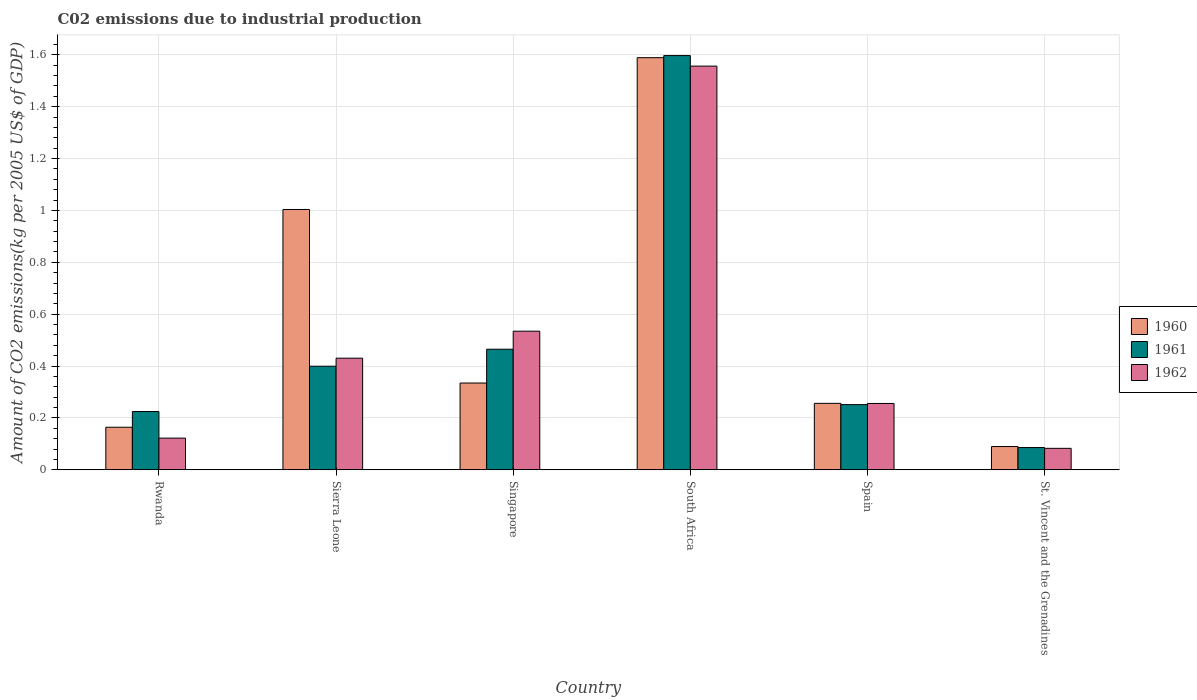Are the number of bars per tick equal to the number of legend labels?
Make the answer very short. Yes. How many bars are there on the 6th tick from the left?
Your answer should be very brief. 3. What is the label of the 4th group of bars from the left?
Keep it short and to the point. South Africa. What is the amount of CO2 emitted due to industrial production in 1962 in South Africa?
Your answer should be compact. 1.56. Across all countries, what is the maximum amount of CO2 emitted due to industrial production in 1960?
Make the answer very short. 1.59. Across all countries, what is the minimum amount of CO2 emitted due to industrial production in 1961?
Provide a succinct answer. 0.09. In which country was the amount of CO2 emitted due to industrial production in 1961 maximum?
Keep it short and to the point. South Africa. In which country was the amount of CO2 emitted due to industrial production in 1962 minimum?
Your response must be concise. St. Vincent and the Grenadines. What is the total amount of CO2 emitted due to industrial production in 1962 in the graph?
Ensure brevity in your answer.  2.98. What is the difference between the amount of CO2 emitted due to industrial production in 1960 in Rwanda and that in St. Vincent and the Grenadines?
Provide a short and direct response. 0.07. What is the difference between the amount of CO2 emitted due to industrial production in 1960 in Singapore and the amount of CO2 emitted due to industrial production in 1962 in Sierra Leone?
Offer a very short reply. -0.1. What is the average amount of CO2 emitted due to industrial production in 1960 per country?
Keep it short and to the point. 0.57. What is the difference between the amount of CO2 emitted due to industrial production of/in 1960 and amount of CO2 emitted due to industrial production of/in 1962 in Sierra Leone?
Your response must be concise. 0.57. In how many countries, is the amount of CO2 emitted due to industrial production in 1960 greater than 0.7600000000000001 kg?
Provide a short and direct response. 2. What is the ratio of the amount of CO2 emitted due to industrial production in 1960 in Rwanda to that in Spain?
Your answer should be compact. 0.64. Is the difference between the amount of CO2 emitted due to industrial production in 1960 in Sierra Leone and South Africa greater than the difference between the amount of CO2 emitted due to industrial production in 1962 in Sierra Leone and South Africa?
Give a very brief answer. Yes. What is the difference between the highest and the second highest amount of CO2 emitted due to industrial production in 1960?
Ensure brevity in your answer.  -1.25. What is the difference between the highest and the lowest amount of CO2 emitted due to industrial production in 1961?
Give a very brief answer. 1.51. In how many countries, is the amount of CO2 emitted due to industrial production in 1961 greater than the average amount of CO2 emitted due to industrial production in 1961 taken over all countries?
Your response must be concise. 1. Is the sum of the amount of CO2 emitted due to industrial production in 1960 in Rwanda and Spain greater than the maximum amount of CO2 emitted due to industrial production in 1962 across all countries?
Offer a very short reply. No. What does the 2nd bar from the left in Sierra Leone represents?
Keep it short and to the point. 1961. What does the 3rd bar from the right in Singapore represents?
Make the answer very short. 1960. Is it the case that in every country, the sum of the amount of CO2 emitted due to industrial production in 1961 and amount of CO2 emitted due to industrial production in 1962 is greater than the amount of CO2 emitted due to industrial production in 1960?
Your answer should be very brief. No. How many bars are there?
Provide a short and direct response. 18. What is the difference between two consecutive major ticks on the Y-axis?
Your answer should be compact. 0.2. Does the graph contain grids?
Make the answer very short. Yes. How are the legend labels stacked?
Ensure brevity in your answer.  Vertical. What is the title of the graph?
Offer a very short reply. C02 emissions due to industrial production. Does "1994" appear as one of the legend labels in the graph?
Offer a terse response. No. What is the label or title of the Y-axis?
Your answer should be very brief. Amount of CO2 emissions(kg per 2005 US$ of GDP). What is the Amount of CO2 emissions(kg per 2005 US$ of GDP) of 1960 in Rwanda?
Ensure brevity in your answer.  0.16. What is the Amount of CO2 emissions(kg per 2005 US$ of GDP) of 1961 in Rwanda?
Keep it short and to the point. 0.22. What is the Amount of CO2 emissions(kg per 2005 US$ of GDP) in 1962 in Rwanda?
Ensure brevity in your answer.  0.12. What is the Amount of CO2 emissions(kg per 2005 US$ of GDP) in 1960 in Sierra Leone?
Provide a short and direct response. 1. What is the Amount of CO2 emissions(kg per 2005 US$ of GDP) of 1961 in Sierra Leone?
Provide a short and direct response. 0.4. What is the Amount of CO2 emissions(kg per 2005 US$ of GDP) in 1962 in Sierra Leone?
Make the answer very short. 0.43. What is the Amount of CO2 emissions(kg per 2005 US$ of GDP) of 1960 in Singapore?
Your response must be concise. 0.33. What is the Amount of CO2 emissions(kg per 2005 US$ of GDP) in 1961 in Singapore?
Keep it short and to the point. 0.46. What is the Amount of CO2 emissions(kg per 2005 US$ of GDP) of 1962 in Singapore?
Offer a very short reply. 0.53. What is the Amount of CO2 emissions(kg per 2005 US$ of GDP) of 1960 in South Africa?
Provide a short and direct response. 1.59. What is the Amount of CO2 emissions(kg per 2005 US$ of GDP) of 1961 in South Africa?
Your answer should be compact. 1.6. What is the Amount of CO2 emissions(kg per 2005 US$ of GDP) of 1962 in South Africa?
Offer a terse response. 1.56. What is the Amount of CO2 emissions(kg per 2005 US$ of GDP) in 1960 in Spain?
Offer a terse response. 0.26. What is the Amount of CO2 emissions(kg per 2005 US$ of GDP) of 1961 in Spain?
Provide a short and direct response. 0.25. What is the Amount of CO2 emissions(kg per 2005 US$ of GDP) of 1962 in Spain?
Provide a short and direct response. 0.26. What is the Amount of CO2 emissions(kg per 2005 US$ of GDP) of 1960 in St. Vincent and the Grenadines?
Your answer should be compact. 0.09. What is the Amount of CO2 emissions(kg per 2005 US$ of GDP) in 1961 in St. Vincent and the Grenadines?
Ensure brevity in your answer.  0.09. What is the Amount of CO2 emissions(kg per 2005 US$ of GDP) in 1962 in St. Vincent and the Grenadines?
Your answer should be very brief. 0.08. Across all countries, what is the maximum Amount of CO2 emissions(kg per 2005 US$ of GDP) in 1960?
Provide a short and direct response. 1.59. Across all countries, what is the maximum Amount of CO2 emissions(kg per 2005 US$ of GDP) in 1961?
Offer a terse response. 1.6. Across all countries, what is the maximum Amount of CO2 emissions(kg per 2005 US$ of GDP) of 1962?
Your answer should be compact. 1.56. Across all countries, what is the minimum Amount of CO2 emissions(kg per 2005 US$ of GDP) of 1960?
Your response must be concise. 0.09. Across all countries, what is the minimum Amount of CO2 emissions(kg per 2005 US$ of GDP) in 1961?
Offer a very short reply. 0.09. Across all countries, what is the minimum Amount of CO2 emissions(kg per 2005 US$ of GDP) of 1962?
Your answer should be compact. 0.08. What is the total Amount of CO2 emissions(kg per 2005 US$ of GDP) in 1960 in the graph?
Ensure brevity in your answer.  3.44. What is the total Amount of CO2 emissions(kg per 2005 US$ of GDP) in 1961 in the graph?
Offer a terse response. 3.02. What is the total Amount of CO2 emissions(kg per 2005 US$ of GDP) in 1962 in the graph?
Keep it short and to the point. 2.98. What is the difference between the Amount of CO2 emissions(kg per 2005 US$ of GDP) in 1960 in Rwanda and that in Sierra Leone?
Offer a terse response. -0.84. What is the difference between the Amount of CO2 emissions(kg per 2005 US$ of GDP) of 1961 in Rwanda and that in Sierra Leone?
Your answer should be compact. -0.17. What is the difference between the Amount of CO2 emissions(kg per 2005 US$ of GDP) of 1962 in Rwanda and that in Sierra Leone?
Give a very brief answer. -0.31. What is the difference between the Amount of CO2 emissions(kg per 2005 US$ of GDP) in 1960 in Rwanda and that in Singapore?
Provide a short and direct response. -0.17. What is the difference between the Amount of CO2 emissions(kg per 2005 US$ of GDP) in 1961 in Rwanda and that in Singapore?
Provide a short and direct response. -0.24. What is the difference between the Amount of CO2 emissions(kg per 2005 US$ of GDP) in 1962 in Rwanda and that in Singapore?
Ensure brevity in your answer.  -0.41. What is the difference between the Amount of CO2 emissions(kg per 2005 US$ of GDP) in 1960 in Rwanda and that in South Africa?
Your response must be concise. -1.42. What is the difference between the Amount of CO2 emissions(kg per 2005 US$ of GDP) in 1961 in Rwanda and that in South Africa?
Ensure brevity in your answer.  -1.37. What is the difference between the Amount of CO2 emissions(kg per 2005 US$ of GDP) in 1962 in Rwanda and that in South Africa?
Provide a succinct answer. -1.43. What is the difference between the Amount of CO2 emissions(kg per 2005 US$ of GDP) in 1960 in Rwanda and that in Spain?
Give a very brief answer. -0.09. What is the difference between the Amount of CO2 emissions(kg per 2005 US$ of GDP) in 1961 in Rwanda and that in Spain?
Give a very brief answer. -0.03. What is the difference between the Amount of CO2 emissions(kg per 2005 US$ of GDP) of 1962 in Rwanda and that in Spain?
Provide a succinct answer. -0.13. What is the difference between the Amount of CO2 emissions(kg per 2005 US$ of GDP) of 1960 in Rwanda and that in St. Vincent and the Grenadines?
Offer a terse response. 0.07. What is the difference between the Amount of CO2 emissions(kg per 2005 US$ of GDP) in 1961 in Rwanda and that in St. Vincent and the Grenadines?
Your response must be concise. 0.14. What is the difference between the Amount of CO2 emissions(kg per 2005 US$ of GDP) of 1962 in Rwanda and that in St. Vincent and the Grenadines?
Offer a terse response. 0.04. What is the difference between the Amount of CO2 emissions(kg per 2005 US$ of GDP) in 1960 in Sierra Leone and that in Singapore?
Ensure brevity in your answer.  0.67. What is the difference between the Amount of CO2 emissions(kg per 2005 US$ of GDP) of 1961 in Sierra Leone and that in Singapore?
Your response must be concise. -0.07. What is the difference between the Amount of CO2 emissions(kg per 2005 US$ of GDP) of 1962 in Sierra Leone and that in Singapore?
Give a very brief answer. -0.1. What is the difference between the Amount of CO2 emissions(kg per 2005 US$ of GDP) of 1960 in Sierra Leone and that in South Africa?
Provide a short and direct response. -0.59. What is the difference between the Amount of CO2 emissions(kg per 2005 US$ of GDP) of 1961 in Sierra Leone and that in South Africa?
Keep it short and to the point. -1.2. What is the difference between the Amount of CO2 emissions(kg per 2005 US$ of GDP) in 1962 in Sierra Leone and that in South Africa?
Your answer should be compact. -1.13. What is the difference between the Amount of CO2 emissions(kg per 2005 US$ of GDP) in 1960 in Sierra Leone and that in Spain?
Your answer should be compact. 0.75. What is the difference between the Amount of CO2 emissions(kg per 2005 US$ of GDP) in 1961 in Sierra Leone and that in Spain?
Your answer should be compact. 0.15. What is the difference between the Amount of CO2 emissions(kg per 2005 US$ of GDP) of 1962 in Sierra Leone and that in Spain?
Keep it short and to the point. 0.17. What is the difference between the Amount of CO2 emissions(kg per 2005 US$ of GDP) in 1960 in Sierra Leone and that in St. Vincent and the Grenadines?
Make the answer very short. 0.91. What is the difference between the Amount of CO2 emissions(kg per 2005 US$ of GDP) of 1961 in Sierra Leone and that in St. Vincent and the Grenadines?
Provide a succinct answer. 0.31. What is the difference between the Amount of CO2 emissions(kg per 2005 US$ of GDP) of 1962 in Sierra Leone and that in St. Vincent and the Grenadines?
Provide a succinct answer. 0.35. What is the difference between the Amount of CO2 emissions(kg per 2005 US$ of GDP) of 1960 in Singapore and that in South Africa?
Your answer should be compact. -1.25. What is the difference between the Amount of CO2 emissions(kg per 2005 US$ of GDP) of 1961 in Singapore and that in South Africa?
Your response must be concise. -1.13. What is the difference between the Amount of CO2 emissions(kg per 2005 US$ of GDP) of 1962 in Singapore and that in South Africa?
Provide a short and direct response. -1.02. What is the difference between the Amount of CO2 emissions(kg per 2005 US$ of GDP) of 1960 in Singapore and that in Spain?
Provide a short and direct response. 0.08. What is the difference between the Amount of CO2 emissions(kg per 2005 US$ of GDP) of 1961 in Singapore and that in Spain?
Your answer should be very brief. 0.21. What is the difference between the Amount of CO2 emissions(kg per 2005 US$ of GDP) of 1962 in Singapore and that in Spain?
Make the answer very short. 0.28. What is the difference between the Amount of CO2 emissions(kg per 2005 US$ of GDP) of 1960 in Singapore and that in St. Vincent and the Grenadines?
Your response must be concise. 0.24. What is the difference between the Amount of CO2 emissions(kg per 2005 US$ of GDP) of 1961 in Singapore and that in St. Vincent and the Grenadines?
Provide a short and direct response. 0.38. What is the difference between the Amount of CO2 emissions(kg per 2005 US$ of GDP) in 1962 in Singapore and that in St. Vincent and the Grenadines?
Your answer should be compact. 0.45. What is the difference between the Amount of CO2 emissions(kg per 2005 US$ of GDP) of 1960 in South Africa and that in Spain?
Give a very brief answer. 1.33. What is the difference between the Amount of CO2 emissions(kg per 2005 US$ of GDP) of 1961 in South Africa and that in Spain?
Keep it short and to the point. 1.35. What is the difference between the Amount of CO2 emissions(kg per 2005 US$ of GDP) of 1962 in South Africa and that in Spain?
Provide a short and direct response. 1.3. What is the difference between the Amount of CO2 emissions(kg per 2005 US$ of GDP) in 1960 in South Africa and that in St. Vincent and the Grenadines?
Provide a short and direct response. 1.5. What is the difference between the Amount of CO2 emissions(kg per 2005 US$ of GDP) in 1961 in South Africa and that in St. Vincent and the Grenadines?
Give a very brief answer. 1.51. What is the difference between the Amount of CO2 emissions(kg per 2005 US$ of GDP) of 1962 in South Africa and that in St. Vincent and the Grenadines?
Offer a very short reply. 1.47. What is the difference between the Amount of CO2 emissions(kg per 2005 US$ of GDP) of 1960 in Spain and that in St. Vincent and the Grenadines?
Your answer should be very brief. 0.17. What is the difference between the Amount of CO2 emissions(kg per 2005 US$ of GDP) of 1961 in Spain and that in St. Vincent and the Grenadines?
Provide a succinct answer. 0.17. What is the difference between the Amount of CO2 emissions(kg per 2005 US$ of GDP) of 1962 in Spain and that in St. Vincent and the Grenadines?
Offer a terse response. 0.17. What is the difference between the Amount of CO2 emissions(kg per 2005 US$ of GDP) of 1960 in Rwanda and the Amount of CO2 emissions(kg per 2005 US$ of GDP) of 1961 in Sierra Leone?
Keep it short and to the point. -0.24. What is the difference between the Amount of CO2 emissions(kg per 2005 US$ of GDP) in 1960 in Rwanda and the Amount of CO2 emissions(kg per 2005 US$ of GDP) in 1962 in Sierra Leone?
Your response must be concise. -0.27. What is the difference between the Amount of CO2 emissions(kg per 2005 US$ of GDP) in 1961 in Rwanda and the Amount of CO2 emissions(kg per 2005 US$ of GDP) in 1962 in Sierra Leone?
Offer a terse response. -0.21. What is the difference between the Amount of CO2 emissions(kg per 2005 US$ of GDP) in 1960 in Rwanda and the Amount of CO2 emissions(kg per 2005 US$ of GDP) in 1961 in Singapore?
Provide a short and direct response. -0.3. What is the difference between the Amount of CO2 emissions(kg per 2005 US$ of GDP) in 1960 in Rwanda and the Amount of CO2 emissions(kg per 2005 US$ of GDP) in 1962 in Singapore?
Offer a terse response. -0.37. What is the difference between the Amount of CO2 emissions(kg per 2005 US$ of GDP) in 1961 in Rwanda and the Amount of CO2 emissions(kg per 2005 US$ of GDP) in 1962 in Singapore?
Your response must be concise. -0.31. What is the difference between the Amount of CO2 emissions(kg per 2005 US$ of GDP) of 1960 in Rwanda and the Amount of CO2 emissions(kg per 2005 US$ of GDP) of 1961 in South Africa?
Your answer should be very brief. -1.43. What is the difference between the Amount of CO2 emissions(kg per 2005 US$ of GDP) of 1960 in Rwanda and the Amount of CO2 emissions(kg per 2005 US$ of GDP) of 1962 in South Africa?
Your response must be concise. -1.39. What is the difference between the Amount of CO2 emissions(kg per 2005 US$ of GDP) of 1961 in Rwanda and the Amount of CO2 emissions(kg per 2005 US$ of GDP) of 1962 in South Africa?
Keep it short and to the point. -1.33. What is the difference between the Amount of CO2 emissions(kg per 2005 US$ of GDP) in 1960 in Rwanda and the Amount of CO2 emissions(kg per 2005 US$ of GDP) in 1961 in Spain?
Offer a terse response. -0.09. What is the difference between the Amount of CO2 emissions(kg per 2005 US$ of GDP) in 1960 in Rwanda and the Amount of CO2 emissions(kg per 2005 US$ of GDP) in 1962 in Spain?
Offer a terse response. -0.09. What is the difference between the Amount of CO2 emissions(kg per 2005 US$ of GDP) in 1961 in Rwanda and the Amount of CO2 emissions(kg per 2005 US$ of GDP) in 1962 in Spain?
Offer a terse response. -0.03. What is the difference between the Amount of CO2 emissions(kg per 2005 US$ of GDP) of 1960 in Rwanda and the Amount of CO2 emissions(kg per 2005 US$ of GDP) of 1961 in St. Vincent and the Grenadines?
Offer a terse response. 0.08. What is the difference between the Amount of CO2 emissions(kg per 2005 US$ of GDP) of 1960 in Rwanda and the Amount of CO2 emissions(kg per 2005 US$ of GDP) of 1962 in St. Vincent and the Grenadines?
Offer a terse response. 0.08. What is the difference between the Amount of CO2 emissions(kg per 2005 US$ of GDP) of 1961 in Rwanda and the Amount of CO2 emissions(kg per 2005 US$ of GDP) of 1962 in St. Vincent and the Grenadines?
Give a very brief answer. 0.14. What is the difference between the Amount of CO2 emissions(kg per 2005 US$ of GDP) in 1960 in Sierra Leone and the Amount of CO2 emissions(kg per 2005 US$ of GDP) in 1961 in Singapore?
Make the answer very short. 0.54. What is the difference between the Amount of CO2 emissions(kg per 2005 US$ of GDP) in 1960 in Sierra Leone and the Amount of CO2 emissions(kg per 2005 US$ of GDP) in 1962 in Singapore?
Provide a succinct answer. 0.47. What is the difference between the Amount of CO2 emissions(kg per 2005 US$ of GDP) in 1961 in Sierra Leone and the Amount of CO2 emissions(kg per 2005 US$ of GDP) in 1962 in Singapore?
Your answer should be very brief. -0.14. What is the difference between the Amount of CO2 emissions(kg per 2005 US$ of GDP) of 1960 in Sierra Leone and the Amount of CO2 emissions(kg per 2005 US$ of GDP) of 1961 in South Africa?
Your response must be concise. -0.59. What is the difference between the Amount of CO2 emissions(kg per 2005 US$ of GDP) of 1960 in Sierra Leone and the Amount of CO2 emissions(kg per 2005 US$ of GDP) of 1962 in South Africa?
Your answer should be compact. -0.55. What is the difference between the Amount of CO2 emissions(kg per 2005 US$ of GDP) in 1961 in Sierra Leone and the Amount of CO2 emissions(kg per 2005 US$ of GDP) in 1962 in South Africa?
Your answer should be compact. -1.16. What is the difference between the Amount of CO2 emissions(kg per 2005 US$ of GDP) of 1960 in Sierra Leone and the Amount of CO2 emissions(kg per 2005 US$ of GDP) of 1961 in Spain?
Offer a very short reply. 0.75. What is the difference between the Amount of CO2 emissions(kg per 2005 US$ of GDP) in 1960 in Sierra Leone and the Amount of CO2 emissions(kg per 2005 US$ of GDP) in 1962 in Spain?
Make the answer very short. 0.75. What is the difference between the Amount of CO2 emissions(kg per 2005 US$ of GDP) of 1961 in Sierra Leone and the Amount of CO2 emissions(kg per 2005 US$ of GDP) of 1962 in Spain?
Your answer should be very brief. 0.14. What is the difference between the Amount of CO2 emissions(kg per 2005 US$ of GDP) in 1960 in Sierra Leone and the Amount of CO2 emissions(kg per 2005 US$ of GDP) in 1961 in St. Vincent and the Grenadines?
Make the answer very short. 0.92. What is the difference between the Amount of CO2 emissions(kg per 2005 US$ of GDP) of 1960 in Sierra Leone and the Amount of CO2 emissions(kg per 2005 US$ of GDP) of 1962 in St. Vincent and the Grenadines?
Offer a terse response. 0.92. What is the difference between the Amount of CO2 emissions(kg per 2005 US$ of GDP) in 1961 in Sierra Leone and the Amount of CO2 emissions(kg per 2005 US$ of GDP) in 1962 in St. Vincent and the Grenadines?
Give a very brief answer. 0.32. What is the difference between the Amount of CO2 emissions(kg per 2005 US$ of GDP) of 1960 in Singapore and the Amount of CO2 emissions(kg per 2005 US$ of GDP) of 1961 in South Africa?
Your answer should be compact. -1.26. What is the difference between the Amount of CO2 emissions(kg per 2005 US$ of GDP) of 1960 in Singapore and the Amount of CO2 emissions(kg per 2005 US$ of GDP) of 1962 in South Africa?
Ensure brevity in your answer.  -1.22. What is the difference between the Amount of CO2 emissions(kg per 2005 US$ of GDP) of 1961 in Singapore and the Amount of CO2 emissions(kg per 2005 US$ of GDP) of 1962 in South Africa?
Provide a succinct answer. -1.09. What is the difference between the Amount of CO2 emissions(kg per 2005 US$ of GDP) in 1960 in Singapore and the Amount of CO2 emissions(kg per 2005 US$ of GDP) in 1961 in Spain?
Offer a terse response. 0.08. What is the difference between the Amount of CO2 emissions(kg per 2005 US$ of GDP) of 1960 in Singapore and the Amount of CO2 emissions(kg per 2005 US$ of GDP) of 1962 in Spain?
Keep it short and to the point. 0.08. What is the difference between the Amount of CO2 emissions(kg per 2005 US$ of GDP) of 1961 in Singapore and the Amount of CO2 emissions(kg per 2005 US$ of GDP) of 1962 in Spain?
Your answer should be compact. 0.21. What is the difference between the Amount of CO2 emissions(kg per 2005 US$ of GDP) in 1960 in Singapore and the Amount of CO2 emissions(kg per 2005 US$ of GDP) in 1961 in St. Vincent and the Grenadines?
Offer a very short reply. 0.25. What is the difference between the Amount of CO2 emissions(kg per 2005 US$ of GDP) in 1960 in Singapore and the Amount of CO2 emissions(kg per 2005 US$ of GDP) in 1962 in St. Vincent and the Grenadines?
Provide a short and direct response. 0.25. What is the difference between the Amount of CO2 emissions(kg per 2005 US$ of GDP) of 1961 in Singapore and the Amount of CO2 emissions(kg per 2005 US$ of GDP) of 1962 in St. Vincent and the Grenadines?
Offer a very short reply. 0.38. What is the difference between the Amount of CO2 emissions(kg per 2005 US$ of GDP) of 1960 in South Africa and the Amount of CO2 emissions(kg per 2005 US$ of GDP) of 1961 in Spain?
Offer a very short reply. 1.34. What is the difference between the Amount of CO2 emissions(kg per 2005 US$ of GDP) of 1960 in South Africa and the Amount of CO2 emissions(kg per 2005 US$ of GDP) of 1962 in Spain?
Provide a short and direct response. 1.33. What is the difference between the Amount of CO2 emissions(kg per 2005 US$ of GDP) of 1961 in South Africa and the Amount of CO2 emissions(kg per 2005 US$ of GDP) of 1962 in Spain?
Your answer should be compact. 1.34. What is the difference between the Amount of CO2 emissions(kg per 2005 US$ of GDP) in 1960 in South Africa and the Amount of CO2 emissions(kg per 2005 US$ of GDP) in 1961 in St. Vincent and the Grenadines?
Your response must be concise. 1.5. What is the difference between the Amount of CO2 emissions(kg per 2005 US$ of GDP) in 1960 in South Africa and the Amount of CO2 emissions(kg per 2005 US$ of GDP) in 1962 in St. Vincent and the Grenadines?
Provide a succinct answer. 1.51. What is the difference between the Amount of CO2 emissions(kg per 2005 US$ of GDP) of 1961 in South Africa and the Amount of CO2 emissions(kg per 2005 US$ of GDP) of 1962 in St. Vincent and the Grenadines?
Offer a terse response. 1.51. What is the difference between the Amount of CO2 emissions(kg per 2005 US$ of GDP) of 1960 in Spain and the Amount of CO2 emissions(kg per 2005 US$ of GDP) of 1961 in St. Vincent and the Grenadines?
Keep it short and to the point. 0.17. What is the difference between the Amount of CO2 emissions(kg per 2005 US$ of GDP) in 1960 in Spain and the Amount of CO2 emissions(kg per 2005 US$ of GDP) in 1962 in St. Vincent and the Grenadines?
Provide a succinct answer. 0.17. What is the difference between the Amount of CO2 emissions(kg per 2005 US$ of GDP) in 1961 in Spain and the Amount of CO2 emissions(kg per 2005 US$ of GDP) in 1962 in St. Vincent and the Grenadines?
Provide a short and direct response. 0.17. What is the average Amount of CO2 emissions(kg per 2005 US$ of GDP) of 1960 per country?
Provide a succinct answer. 0.57. What is the average Amount of CO2 emissions(kg per 2005 US$ of GDP) in 1961 per country?
Make the answer very short. 0.5. What is the average Amount of CO2 emissions(kg per 2005 US$ of GDP) of 1962 per country?
Provide a short and direct response. 0.5. What is the difference between the Amount of CO2 emissions(kg per 2005 US$ of GDP) in 1960 and Amount of CO2 emissions(kg per 2005 US$ of GDP) in 1961 in Rwanda?
Give a very brief answer. -0.06. What is the difference between the Amount of CO2 emissions(kg per 2005 US$ of GDP) of 1960 and Amount of CO2 emissions(kg per 2005 US$ of GDP) of 1962 in Rwanda?
Your answer should be compact. 0.04. What is the difference between the Amount of CO2 emissions(kg per 2005 US$ of GDP) in 1961 and Amount of CO2 emissions(kg per 2005 US$ of GDP) in 1962 in Rwanda?
Your answer should be very brief. 0.1. What is the difference between the Amount of CO2 emissions(kg per 2005 US$ of GDP) of 1960 and Amount of CO2 emissions(kg per 2005 US$ of GDP) of 1961 in Sierra Leone?
Your response must be concise. 0.6. What is the difference between the Amount of CO2 emissions(kg per 2005 US$ of GDP) in 1960 and Amount of CO2 emissions(kg per 2005 US$ of GDP) in 1962 in Sierra Leone?
Ensure brevity in your answer.  0.57. What is the difference between the Amount of CO2 emissions(kg per 2005 US$ of GDP) in 1961 and Amount of CO2 emissions(kg per 2005 US$ of GDP) in 1962 in Sierra Leone?
Provide a succinct answer. -0.03. What is the difference between the Amount of CO2 emissions(kg per 2005 US$ of GDP) in 1960 and Amount of CO2 emissions(kg per 2005 US$ of GDP) in 1961 in Singapore?
Your response must be concise. -0.13. What is the difference between the Amount of CO2 emissions(kg per 2005 US$ of GDP) in 1960 and Amount of CO2 emissions(kg per 2005 US$ of GDP) in 1962 in Singapore?
Ensure brevity in your answer.  -0.2. What is the difference between the Amount of CO2 emissions(kg per 2005 US$ of GDP) in 1961 and Amount of CO2 emissions(kg per 2005 US$ of GDP) in 1962 in Singapore?
Your answer should be compact. -0.07. What is the difference between the Amount of CO2 emissions(kg per 2005 US$ of GDP) in 1960 and Amount of CO2 emissions(kg per 2005 US$ of GDP) in 1961 in South Africa?
Your answer should be very brief. -0.01. What is the difference between the Amount of CO2 emissions(kg per 2005 US$ of GDP) in 1960 and Amount of CO2 emissions(kg per 2005 US$ of GDP) in 1962 in South Africa?
Your answer should be compact. 0.03. What is the difference between the Amount of CO2 emissions(kg per 2005 US$ of GDP) of 1961 and Amount of CO2 emissions(kg per 2005 US$ of GDP) of 1962 in South Africa?
Keep it short and to the point. 0.04. What is the difference between the Amount of CO2 emissions(kg per 2005 US$ of GDP) in 1960 and Amount of CO2 emissions(kg per 2005 US$ of GDP) in 1961 in Spain?
Provide a short and direct response. 0. What is the difference between the Amount of CO2 emissions(kg per 2005 US$ of GDP) of 1961 and Amount of CO2 emissions(kg per 2005 US$ of GDP) of 1962 in Spain?
Offer a terse response. -0. What is the difference between the Amount of CO2 emissions(kg per 2005 US$ of GDP) of 1960 and Amount of CO2 emissions(kg per 2005 US$ of GDP) of 1961 in St. Vincent and the Grenadines?
Your answer should be compact. 0. What is the difference between the Amount of CO2 emissions(kg per 2005 US$ of GDP) of 1960 and Amount of CO2 emissions(kg per 2005 US$ of GDP) of 1962 in St. Vincent and the Grenadines?
Your answer should be very brief. 0.01. What is the difference between the Amount of CO2 emissions(kg per 2005 US$ of GDP) of 1961 and Amount of CO2 emissions(kg per 2005 US$ of GDP) of 1962 in St. Vincent and the Grenadines?
Offer a very short reply. 0. What is the ratio of the Amount of CO2 emissions(kg per 2005 US$ of GDP) of 1960 in Rwanda to that in Sierra Leone?
Provide a short and direct response. 0.16. What is the ratio of the Amount of CO2 emissions(kg per 2005 US$ of GDP) in 1961 in Rwanda to that in Sierra Leone?
Offer a very short reply. 0.56. What is the ratio of the Amount of CO2 emissions(kg per 2005 US$ of GDP) in 1962 in Rwanda to that in Sierra Leone?
Give a very brief answer. 0.28. What is the ratio of the Amount of CO2 emissions(kg per 2005 US$ of GDP) of 1960 in Rwanda to that in Singapore?
Provide a short and direct response. 0.49. What is the ratio of the Amount of CO2 emissions(kg per 2005 US$ of GDP) in 1961 in Rwanda to that in Singapore?
Keep it short and to the point. 0.48. What is the ratio of the Amount of CO2 emissions(kg per 2005 US$ of GDP) of 1962 in Rwanda to that in Singapore?
Keep it short and to the point. 0.23. What is the ratio of the Amount of CO2 emissions(kg per 2005 US$ of GDP) of 1960 in Rwanda to that in South Africa?
Your answer should be compact. 0.1. What is the ratio of the Amount of CO2 emissions(kg per 2005 US$ of GDP) of 1961 in Rwanda to that in South Africa?
Keep it short and to the point. 0.14. What is the ratio of the Amount of CO2 emissions(kg per 2005 US$ of GDP) of 1962 in Rwanda to that in South Africa?
Keep it short and to the point. 0.08. What is the ratio of the Amount of CO2 emissions(kg per 2005 US$ of GDP) of 1960 in Rwanda to that in Spain?
Give a very brief answer. 0.64. What is the ratio of the Amount of CO2 emissions(kg per 2005 US$ of GDP) in 1961 in Rwanda to that in Spain?
Offer a very short reply. 0.89. What is the ratio of the Amount of CO2 emissions(kg per 2005 US$ of GDP) of 1962 in Rwanda to that in Spain?
Offer a very short reply. 0.48. What is the ratio of the Amount of CO2 emissions(kg per 2005 US$ of GDP) in 1960 in Rwanda to that in St. Vincent and the Grenadines?
Provide a succinct answer. 1.83. What is the ratio of the Amount of CO2 emissions(kg per 2005 US$ of GDP) of 1961 in Rwanda to that in St. Vincent and the Grenadines?
Your response must be concise. 2.62. What is the ratio of the Amount of CO2 emissions(kg per 2005 US$ of GDP) in 1962 in Rwanda to that in St. Vincent and the Grenadines?
Provide a short and direct response. 1.48. What is the ratio of the Amount of CO2 emissions(kg per 2005 US$ of GDP) in 1960 in Sierra Leone to that in Singapore?
Give a very brief answer. 3. What is the ratio of the Amount of CO2 emissions(kg per 2005 US$ of GDP) in 1961 in Sierra Leone to that in Singapore?
Ensure brevity in your answer.  0.86. What is the ratio of the Amount of CO2 emissions(kg per 2005 US$ of GDP) of 1962 in Sierra Leone to that in Singapore?
Make the answer very short. 0.81. What is the ratio of the Amount of CO2 emissions(kg per 2005 US$ of GDP) in 1960 in Sierra Leone to that in South Africa?
Your response must be concise. 0.63. What is the ratio of the Amount of CO2 emissions(kg per 2005 US$ of GDP) of 1961 in Sierra Leone to that in South Africa?
Your answer should be very brief. 0.25. What is the ratio of the Amount of CO2 emissions(kg per 2005 US$ of GDP) in 1962 in Sierra Leone to that in South Africa?
Give a very brief answer. 0.28. What is the ratio of the Amount of CO2 emissions(kg per 2005 US$ of GDP) of 1960 in Sierra Leone to that in Spain?
Offer a very short reply. 3.92. What is the ratio of the Amount of CO2 emissions(kg per 2005 US$ of GDP) in 1961 in Sierra Leone to that in Spain?
Ensure brevity in your answer.  1.59. What is the ratio of the Amount of CO2 emissions(kg per 2005 US$ of GDP) of 1962 in Sierra Leone to that in Spain?
Your answer should be very brief. 1.68. What is the ratio of the Amount of CO2 emissions(kg per 2005 US$ of GDP) of 1960 in Sierra Leone to that in St. Vincent and the Grenadines?
Offer a very short reply. 11.19. What is the ratio of the Amount of CO2 emissions(kg per 2005 US$ of GDP) in 1961 in Sierra Leone to that in St. Vincent and the Grenadines?
Your answer should be compact. 4.65. What is the ratio of the Amount of CO2 emissions(kg per 2005 US$ of GDP) in 1962 in Sierra Leone to that in St. Vincent and the Grenadines?
Your answer should be compact. 5.2. What is the ratio of the Amount of CO2 emissions(kg per 2005 US$ of GDP) of 1960 in Singapore to that in South Africa?
Provide a succinct answer. 0.21. What is the ratio of the Amount of CO2 emissions(kg per 2005 US$ of GDP) of 1961 in Singapore to that in South Africa?
Give a very brief answer. 0.29. What is the ratio of the Amount of CO2 emissions(kg per 2005 US$ of GDP) in 1962 in Singapore to that in South Africa?
Your answer should be very brief. 0.34. What is the ratio of the Amount of CO2 emissions(kg per 2005 US$ of GDP) of 1960 in Singapore to that in Spain?
Keep it short and to the point. 1.31. What is the ratio of the Amount of CO2 emissions(kg per 2005 US$ of GDP) in 1961 in Singapore to that in Spain?
Your answer should be very brief. 1.85. What is the ratio of the Amount of CO2 emissions(kg per 2005 US$ of GDP) in 1962 in Singapore to that in Spain?
Provide a succinct answer. 2.09. What is the ratio of the Amount of CO2 emissions(kg per 2005 US$ of GDP) in 1960 in Singapore to that in St. Vincent and the Grenadines?
Ensure brevity in your answer.  3.73. What is the ratio of the Amount of CO2 emissions(kg per 2005 US$ of GDP) in 1961 in Singapore to that in St. Vincent and the Grenadines?
Your response must be concise. 5.42. What is the ratio of the Amount of CO2 emissions(kg per 2005 US$ of GDP) in 1962 in Singapore to that in St. Vincent and the Grenadines?
Make the answer very short. 6.46. What is the ratio of the Amount of CO2 emissions(kg per 2005 US$ of GDP) of 1960 in South Africa to that in Spain?
Your answer should be very brief. 6.2. What is the ratio of the Amount of CO2 emissions(kg per 2005 US$ of GDP) in 1961 in South Africa to that in Spain?
Ensure brevity in your answer.  6.35. What is the ratio of the Amount of CO2 emissions(kg per 2005 US$ of GDP) in 1962 in South Africa to that in Spain?
Keep it short and to the point. 6.09. What is the ratio of the Amount of CO2 emissions(kg per 2005 US$ of GDP) of 1960 in South Africa to that in St. Vincent and the Grenadines?
Keep it short and to the point. 17.72. What is the ratio of the Amount of CO2 emissions(kg per 2005 US$ of GDP) of 1961 in South Africa to that in St. Vincent and the Grenadines?
Your answer should be very brief. 18.61. What is the ratio of the Amount of CO2 emissions(kg per 2005 US$ of GDP) in 1962 in South Africa to that in St. Vincent and the Grenadines?
Keep it short and to the point. 18.81. What is the ratio of the Amount of CO2 emissions(kg per 2005 US$ of GDP) of 1960 in Spain to that in St. Vincent and the Grenadines?
Provide a short and direct response. 2.86. What is the ratio of the Amount of CO2 emissions(kg per 2005 US$ of GDP) in 1961 in Spain to that in St. Vincent and the Grenadines?
Keep it short and to the point. 2.93. What is the ratio of the Amount of CO2 emissions(kg per 2005 US$ of GDP) in 1962 in Spain to that in St. Vincent and the Grenadines?
Ensure brevity in your answer.  3.09. What is the difference between the highest and the second highest Amount of CO2 emissions(kg per 2005 US$ of GDP) in 1960?
Keep it short and to the point. 0.59. What is the difference between the highest and the second highest Amount of CO2 emissions(kg per 2005 US$ of GDP) in 1961?
Your answer should be compact. 1.13. What is the difference between the highest and the second highest Amount of CO2 emissions(kg per 2005 US$ of GDP) in 1962?
Make the answer very short. 1.02. What is the difference between the highest and the lowest Amount of CO2 emissions(kg per 2005 US$ of GDP) in 1960?
Your answer should be very brief. 1.5. What is the difference between the highest and the lowest Amount of CO2 emissions(kg per 2005 US$ of GDP) in 1961?
Provide a succinct answer. 1.51. What is the difference between the highest and the lowest Amount of CO2 emissions(kg per 2005 US$ of GDP) in 1962?
Keep it short and to the point. 1.47. 